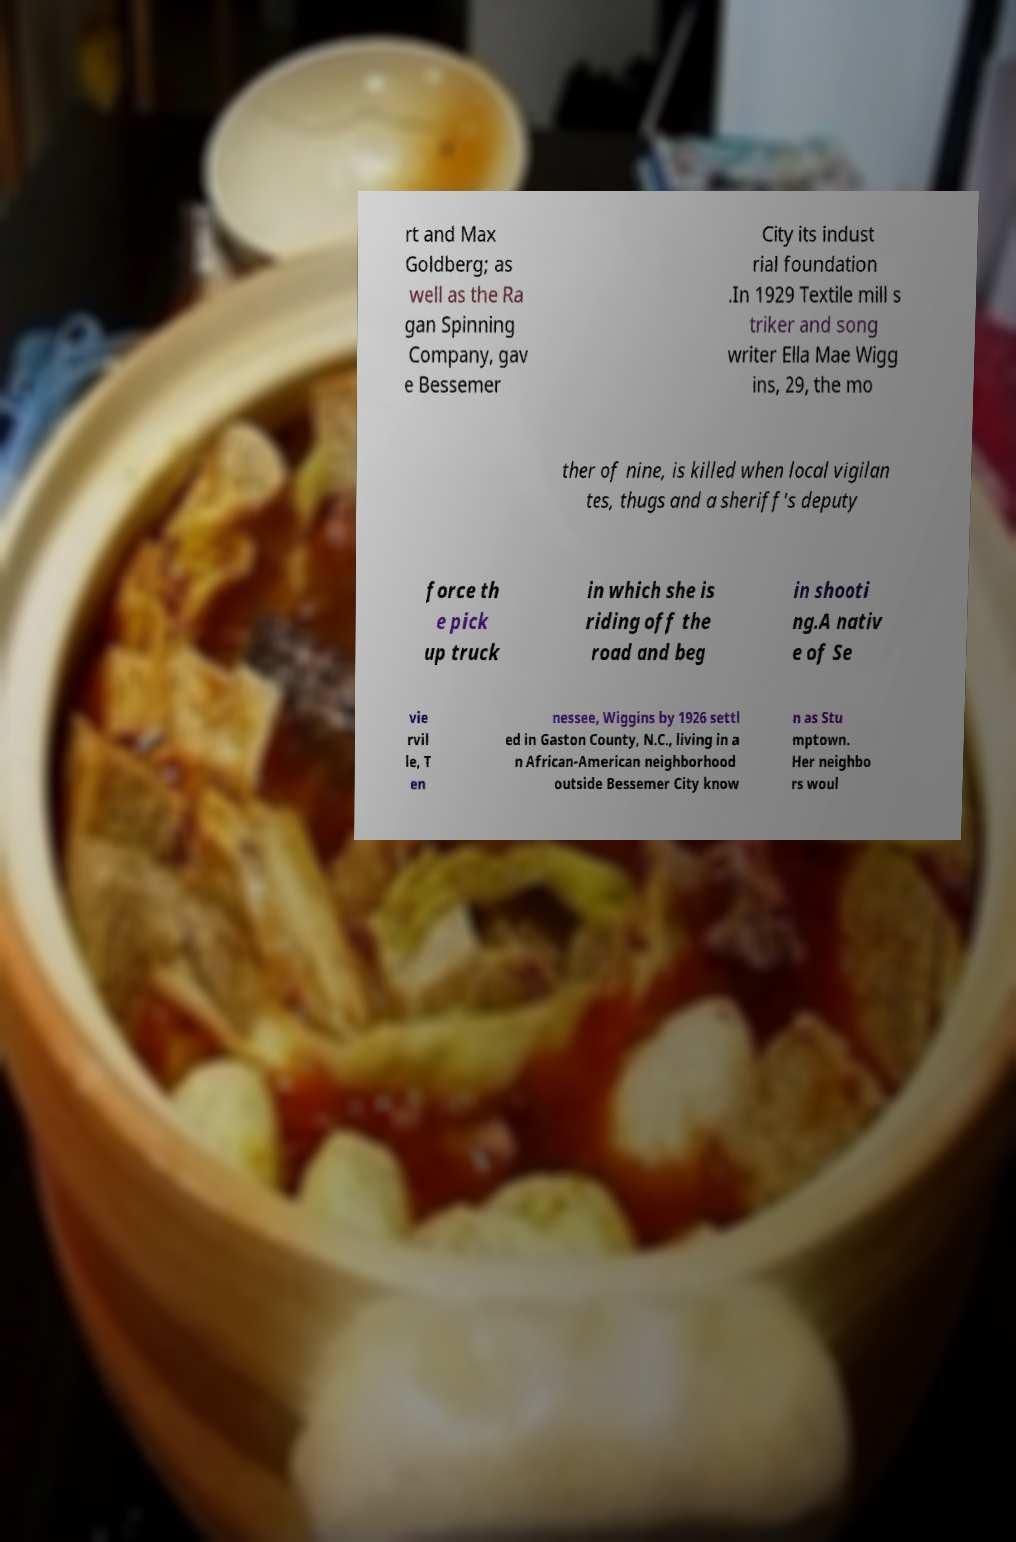What messages or text are displayed in this image? I need them in a readable, typed format. rt and Max Goldberg; as well as the Ra gan Spinning Company, gav e Bessemer City its indust rial foundation .In 1929 Textile mill s triker and song writer Ella Mae Wigg ins, 29, the mo ther of nine, is killed when local vigilan tes, thugs and a sheriff's deputy force th e pick up truck in which she is riding off the road and beg in shooti ng.A nativ e of Se vie rvil le, T en nessee, Wiggins by 1926 settl ed in Gaston County, N.C., living in a n African-American neighborhood outside Bessemer City know n as Stu mptown. Her neighbo rs woul 